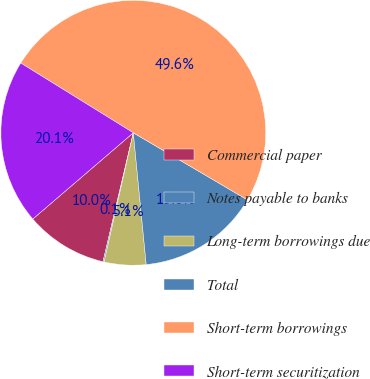Convert chart to OTSL. <chart><loc_0><loc_0><loc_500><loc_500><pie_chart><fcel>Commercial paper<fcel>Notes payable to banks<fcel>Long-term borrowings due<fcel>Total<fcel>Short-term borrowings<fcel>Short-term securitization<nl><fcel>10.04%<fcel>0.14%<fcel>5.09%<fcel>14.99%<fcel>49.63%<fcel>20.12%<nl></chart> 